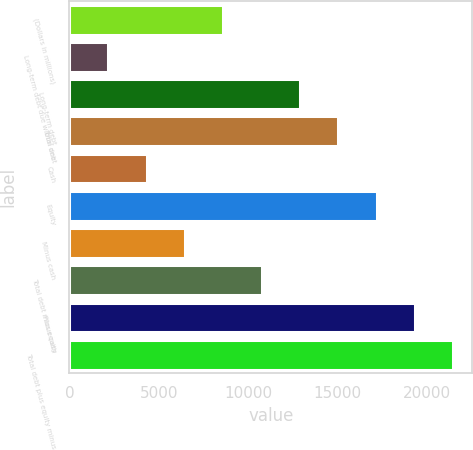Convert chart to OTSL. <chart><loc_0><loc_0><loc_500><loc_500><bar_chart><fcel>(Dollars in millions)<fcel>Long-term debt due within one<fcel>Long-term debt<fcel>Total debt<fcel>Cash<fcel>Equity<fcel>Minus cash<fcel>Total debt minus cash<fcel>Plus equity<fcel>Total debt plus equity minus<nl><fcel>8604.4<fcel>2166.1<fcel>12896.6<fcel>15042.7<fcel>4312.2<fcel>17188.8<fcel>6458.3<fcel>10750.5<fcel>19334.9<fcel>21481<nl></chart> 